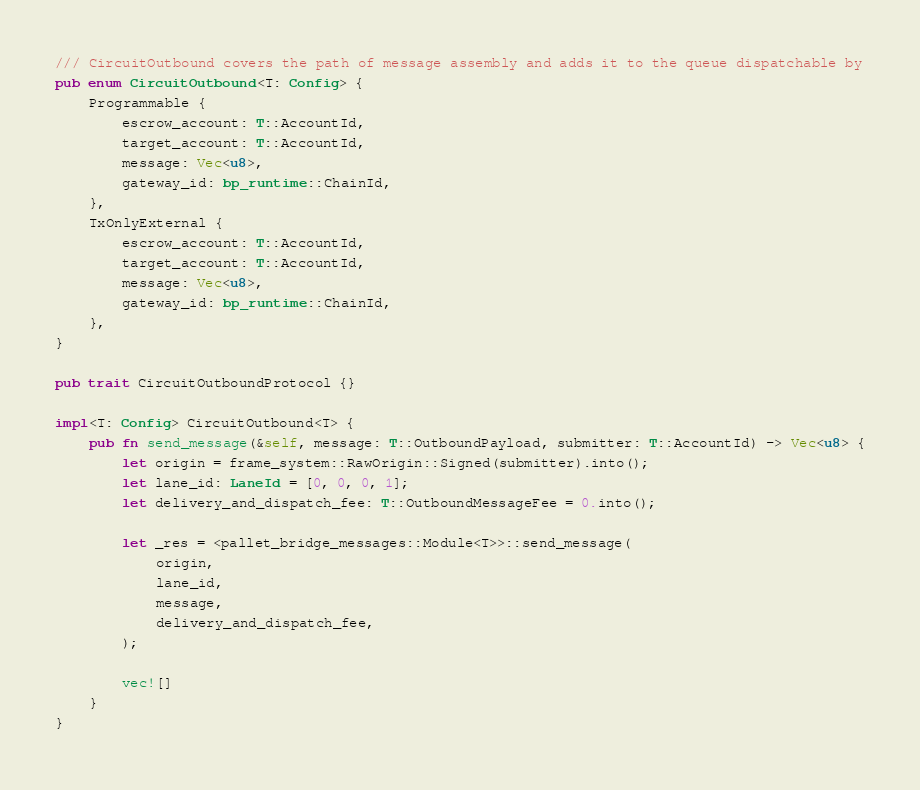<code> <loc_0><loc_0><loc_500><loc_500><_Rust_>/// CircuitOutbound covers the path of message assembly and adds it to the queue dispatchable by
pub enum CircuitOutbound<T: Config> {
    Programmable {
        escrow_account: T::AccountId,
        target_account: T::AccountId,
        message: Vec<u8>,
        gateway_id: bp_runtime::ChainId,
    },
    TxOnlyExternal {
        escrow_account: T::AccountId,
        target_account: T::AccountId,
        message: Vec<u8>,
        gateway_id: bp_runtime::ChainId,
    },
}

pub trait CircuitOutboundProtocol {}

impl<T: Config> CircuitOutbound<T> {
    pub fn send_message(&self, message: T::OutboundPayload, submitter: T::AccountId) -> Vec<u8> {
        let origin = frame_system::RawOrigin::Signed(submitter).into();
        let lane_id: LaneId = [0, 0, 0, 1];
        let delivery_and_dispatch_fee: T::OutboundMessageFee = 0.into();

        let _res = <pallet_bridge_messages::Module<T>>::send_message(
            origin,
            lane_id,
            message,
            delivery_and_dispatch_fee,
        );

        vec![]
    }
}
</code> 